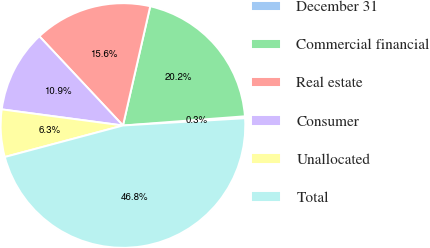Convert chart. <chart><loc_0><loc_0><loc_500><loc_500><pie_chart><fcel>December 31<fcel>Commercial financial<fcel>Real estate<fcel>Consumer<fcel>Unallocated<fcel>Total<nl><fcel>0.25%<fcel>20.22%<fcel>15.56%<fcel>10.91%<fcel>6.25%<fcel>46.8%<nl></chart> 